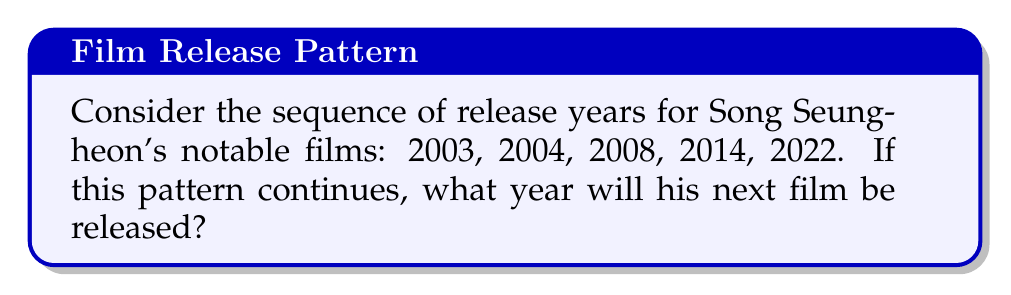Help me with this question. Let's analyze the sequence step-by-step:

1. Calculate the differences between consecutive years:
   $2004 - 2003 = 1$
   $2008 - 2004 = 4$
   $2014 - 2008 = 6$
   $2022 - 2014 = 8$

2. Observe the pattern in these differences:
   $1, 4, 6, 8$

3. The differences form an arithmetic sequence with a common difference of 2:
   $4 - 1 = 3$
   $6 - 4 = 2$
   $8 - 6 = 2$

4. The next difference in this pattern would be:
   $8 + 2 = 10$

5. To find the next year in the original sequence, add this difference to the last known year:
   $2022 + 10 = 2032$

Therefore, if the pattern continues, Song Seung-heon's next film would be released in 2032.
Answer: 2032 